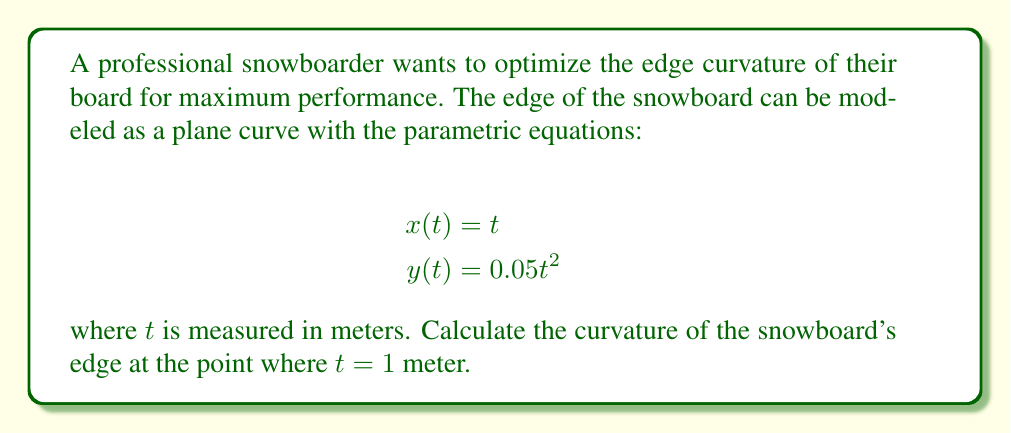Provide a solution to this math problem. To calculate the curvature of a plane curve given by parametric equations, we can use the formula:

$$\kappa = \frac{|x'y'' - y'x''|}{(x'^2 + y'^2)^{3/2}}$$

where $x'$ and $y'$ are the first derivatives, and $x''$ and $y''$ are the second derivatives with respect to $t$.

Step 1: Calculate the first derivatives
$$x'(t) = 1$$
$$y'(t) = 0.1t$$

Step 2: Calculate the second derivatives
$$x''(t) = 0$$
$$y''(t) = 0.1$$

Step 3: Evaluate the derivatives at $t = 1$
$$x'(1) = 1$$
$$y'(1) = 0.1$$
$$x''(1) = 0$$
$$y''(1) = 0.1$$

Step 4: Substitute the values into the curvature formula
$$\kappa = \frac{|1 \cdot 0.1 - 0.1 \cdot 0|}{(1^2 + 0.1^2)^{3/2}}$$

Step 5: Simplify and calculate
$$\kappa = \frac{0.1}{(1.01)^{3/2}} \approx 0.0990$$

The curvature of the snowboard's edge at $t = 1$ meter is approximately 0.0990 m^(-1).
Answer: $$\kappa \approx 0.0990 \text{ m}^{-1}$$ 